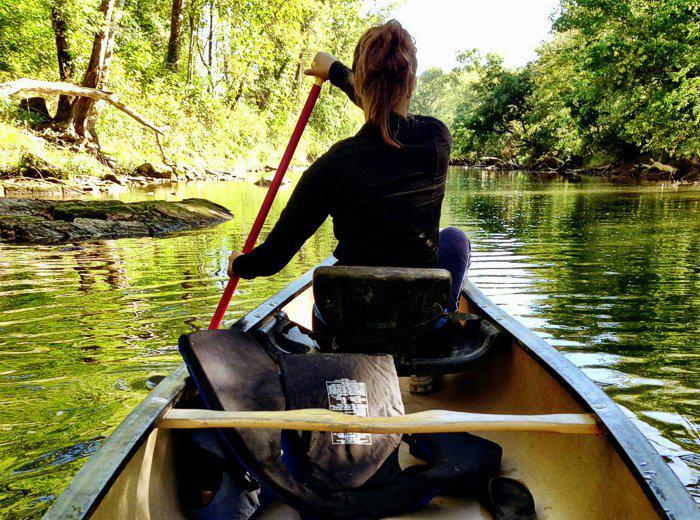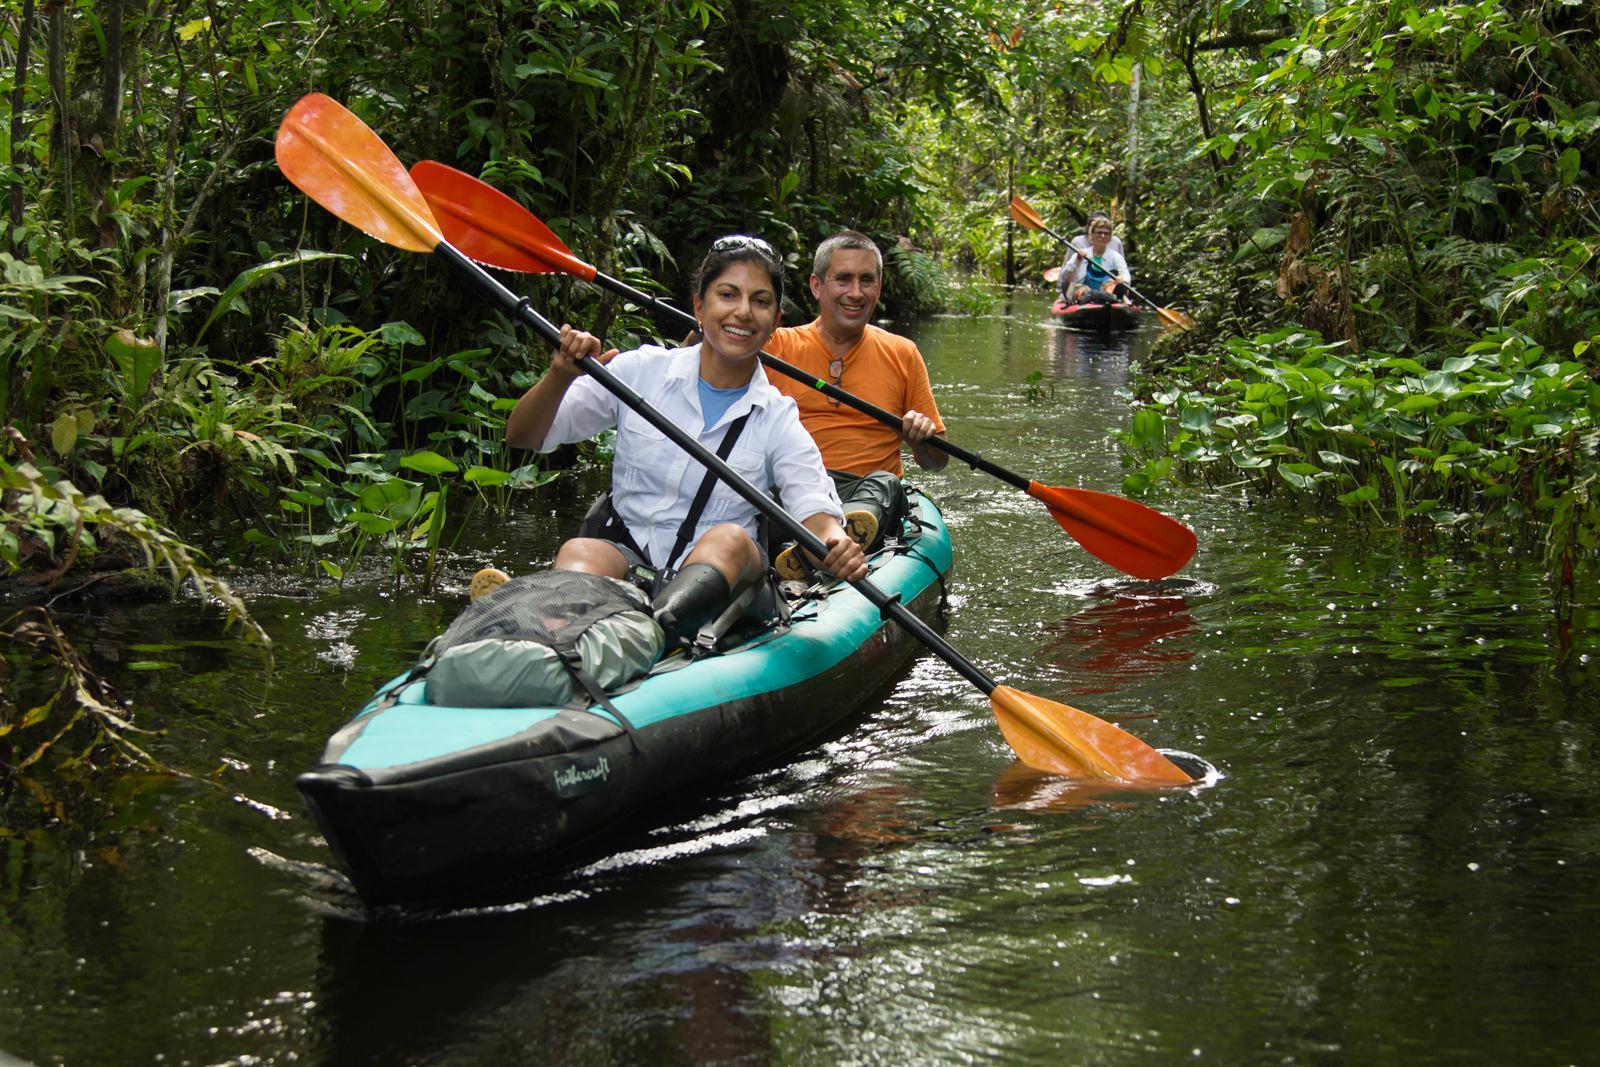The first image is the image on the left, the second image is the image on the right. For the images shown, is this caption "In the image on the right, four people are riding in one canoe." true? Answer yes or no. No. The first image is the image on the left, the second image is the image on the right. Given the left and right images, does the statement "The left image includes a canoe in the foreground heading away from the camera, and the right image shows at least one forward moving kayak-type boat." hold true? Answer yes or no. Yes. 